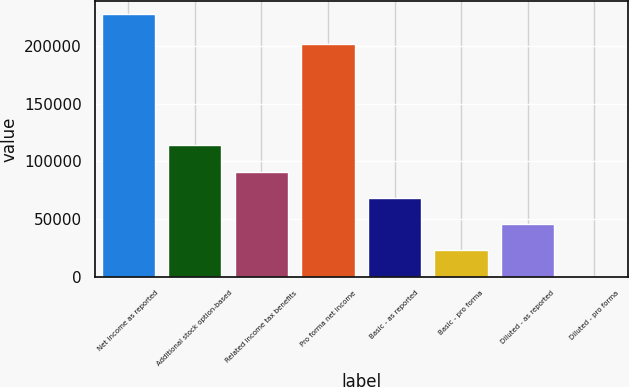<chart> <loc_0><loc_0><loc_500><loc_500><bar_chart><fcel>Net income as reported<fcel>Additional stock option-based<fcel>Related income tax benefits<fcel>Pro forma net income<fcel>Basic - as reported<fcel>Basic - pro forma<fcel>Diluted - as reported<fcel>Diluted - pro forma<nl><fcel>227487<fcel>113744<fcel>90995.8<fcel>201707<fcel>68247.2<fcel>22750.1<fcel>45498.7<fcel>1.59<nl></chart> 